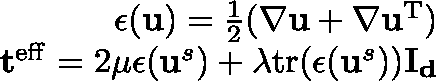<formula> <loc_0><loc_0><loc_500><loc_500>\begin{array} { r } { \epsilon ( u ) = \frac { 1 } { 2 } ( \nabla u + \nabla u ^ { T } ) } \\ { t ^ { e f f } = 2 \mu \epsilon ( u ^ { s } ) + \lambda t r ( \epsilon ( u ^ { s } ) ) I _ { d } } \end{array}</formula> 